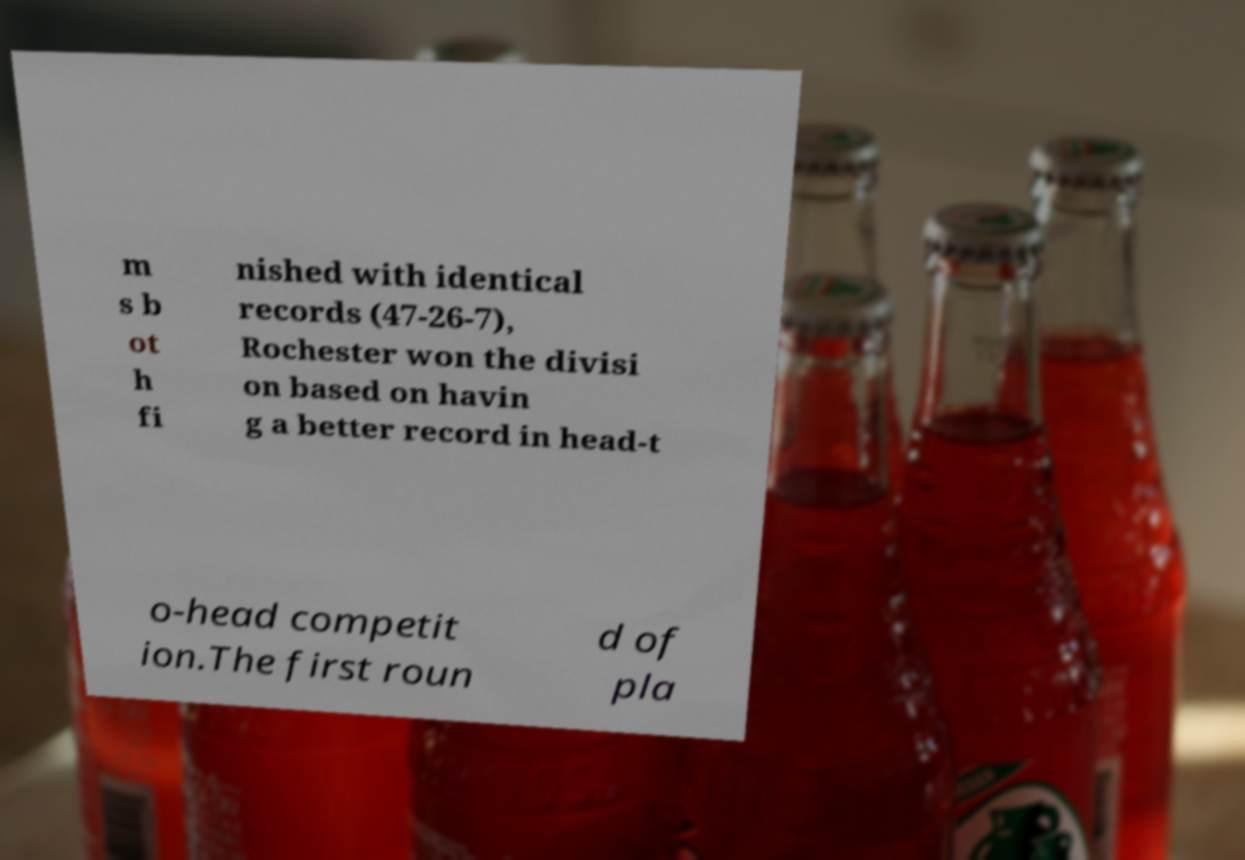Please read and relay the text visible in this image. What does it say? m s b ot h fi nished with identical records (47-26-7), Rochester won the divisi on based on havin g a better record in head-t o-head competit ion.The first roun d of pla 